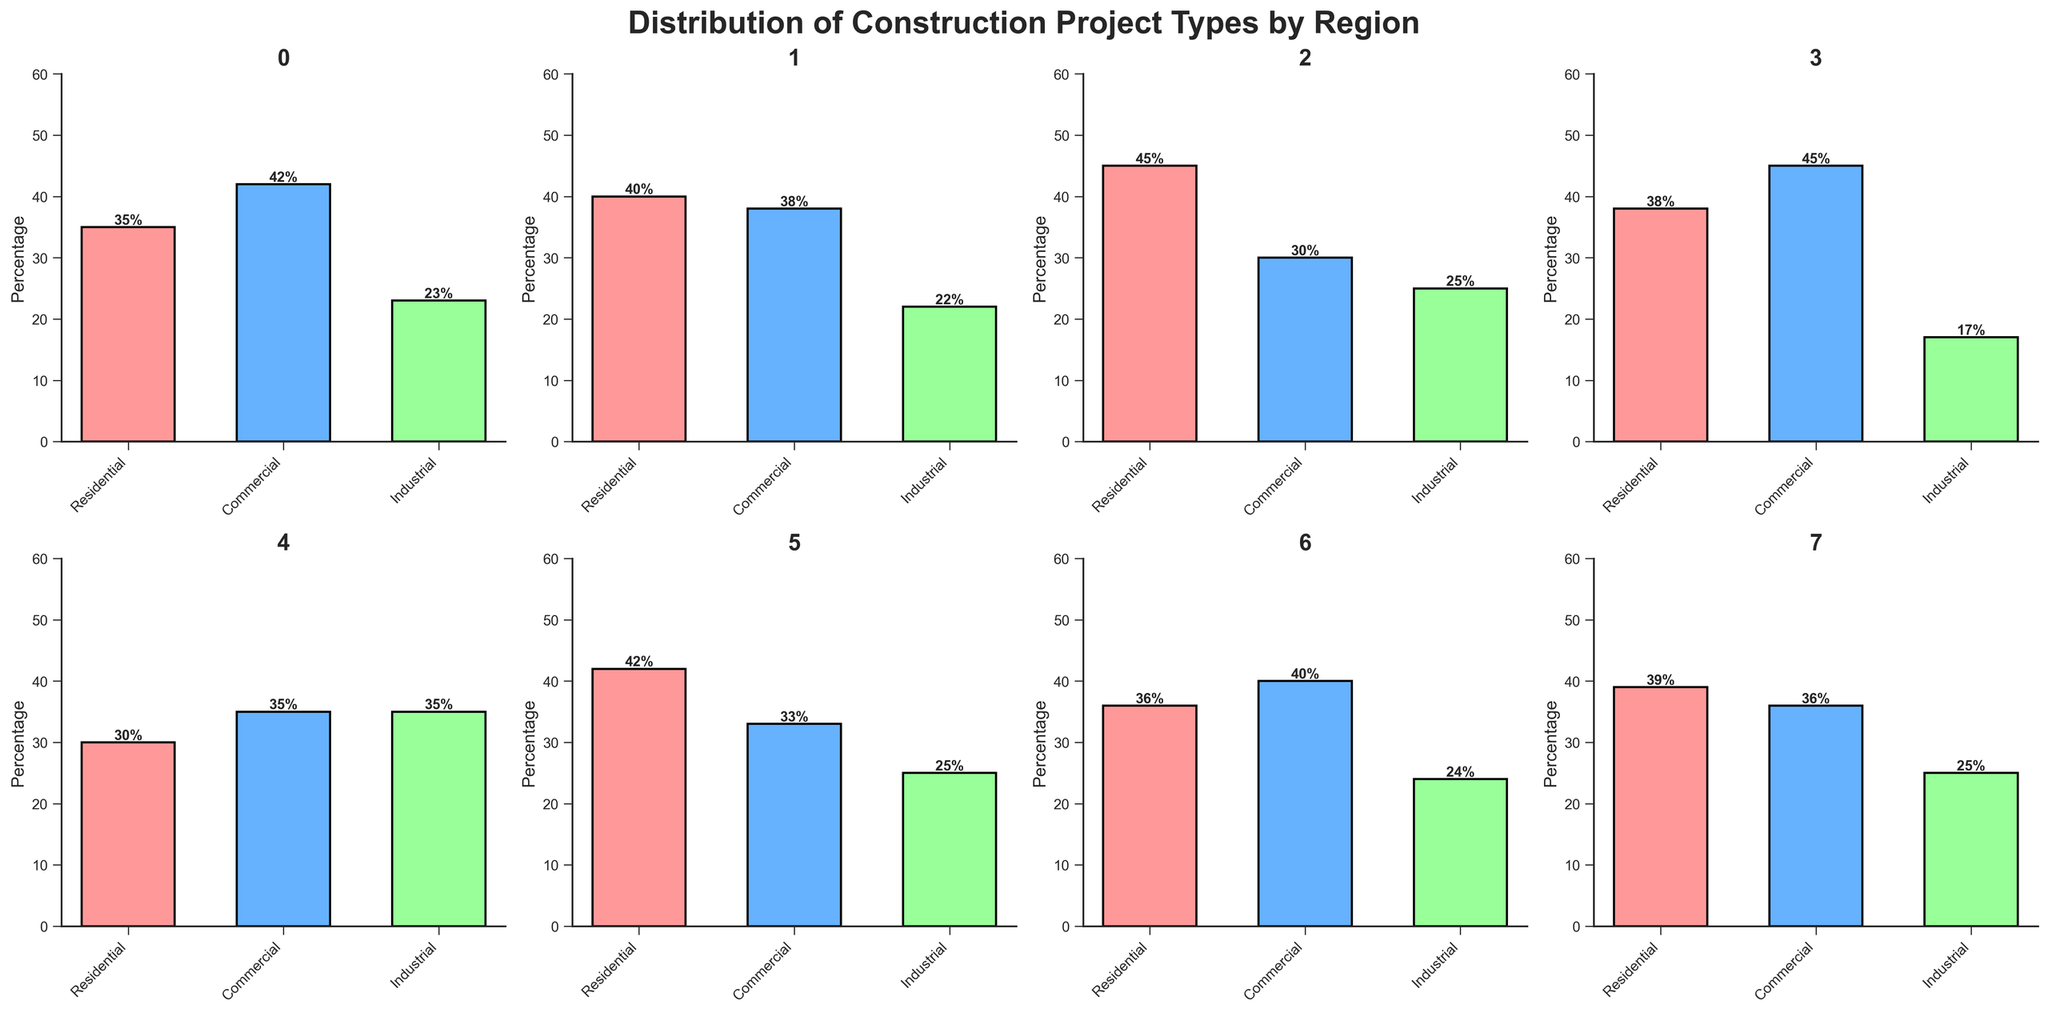What's the title of the figure? The title of the figure is displayed at the top center in a larger, bold font which reads "Distribution of Construction Project Types by Region."
Answer: Distribution of Construction Project Types by Region What are the three types of construction projects shown in the figure? By looking at the x-axis labels for each bar chart, we see that the three types of construction projects are "Residential," "Commercial," and "Industrial."
Answer: Residential, Commercial, Industrial Which region has the highest percentage of Residential projects? Inspect each of the subplots and identify the bar representing Residential projects. The highest bar among these is in the South region with a height of 45%.
Answer: South How many regions have more Commercial projects than Residential projects? We compare the Commercial and Residential bars in each subplot. The regions where Commercial is higher are Northeast, West, Northwest, and Southwest. Therefore, there are 4 regions.
Answer: 4 In which region are Industrial projects the most dominant type? We check for the tallest Industrial bar among all subplots. The Southwest region has a bar of 35%, which is the highest Industrial proportion.
Answer: Southwest What’s the average percentage of Industrial projects across all regions? Add the Industrial percentage values from all regions: 23 + 22 + 25 + 17 + 35 + 25 + 24 + 25 = 196. Divide this sum by the number of regions, which is 8. The average is 196 / 8 = 24.5%
Answer: 24.5% Which region has the most evenly distributed percentages across all three project types? Look for the subplot where the bars are closest in height. The Southwest has bars of 30%, 35%, and 35%, which are quite even in comparison to other regions.
Answer: Southwest What is the total percentage of Residential and Industrial projects combined in the Midwest region? Sum the Residential and Industrial percentages for the Midwest region: 40% + 22% = 62%.
Answer: 62% Which region has the smallest percentage of Commercial projects? Identify the shortest bar representing Commercial projects among all subplots. The South region has the smallest at 30%.
Answer: South By how many percentage points does the Commercial project type in the West exceed the Industrial project type in the same region? Subtract the percentage of Industrial projects from Commercial projects in the West region: 45% - 17% = 28 percentage points.
Answer: 28% 